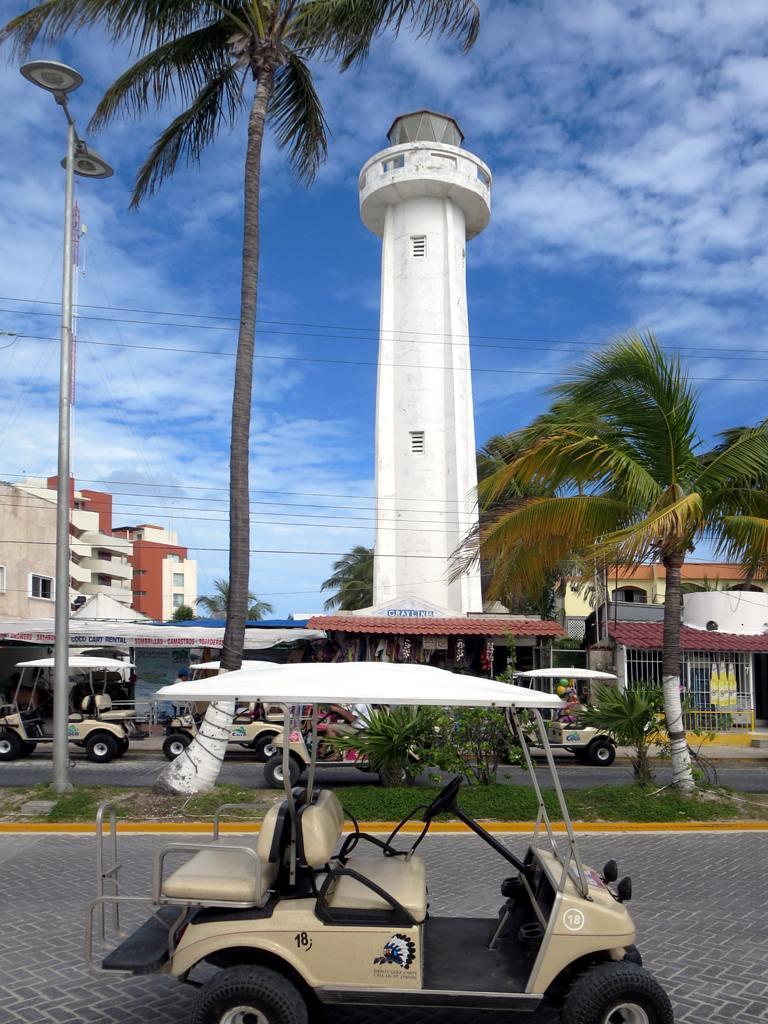How would you summarize this image in a sentence or two? This image is taken outdoors. At the bottom of the image there is a road and a vehicle is parked on the road. At the top of the image there is a sky with clouds. In the middle of the image there is a tower. In the background a few vehicles are moving on the road and there are a few buildings and houses. On the left side of the image there is a street light. In the background there are a few trees. 